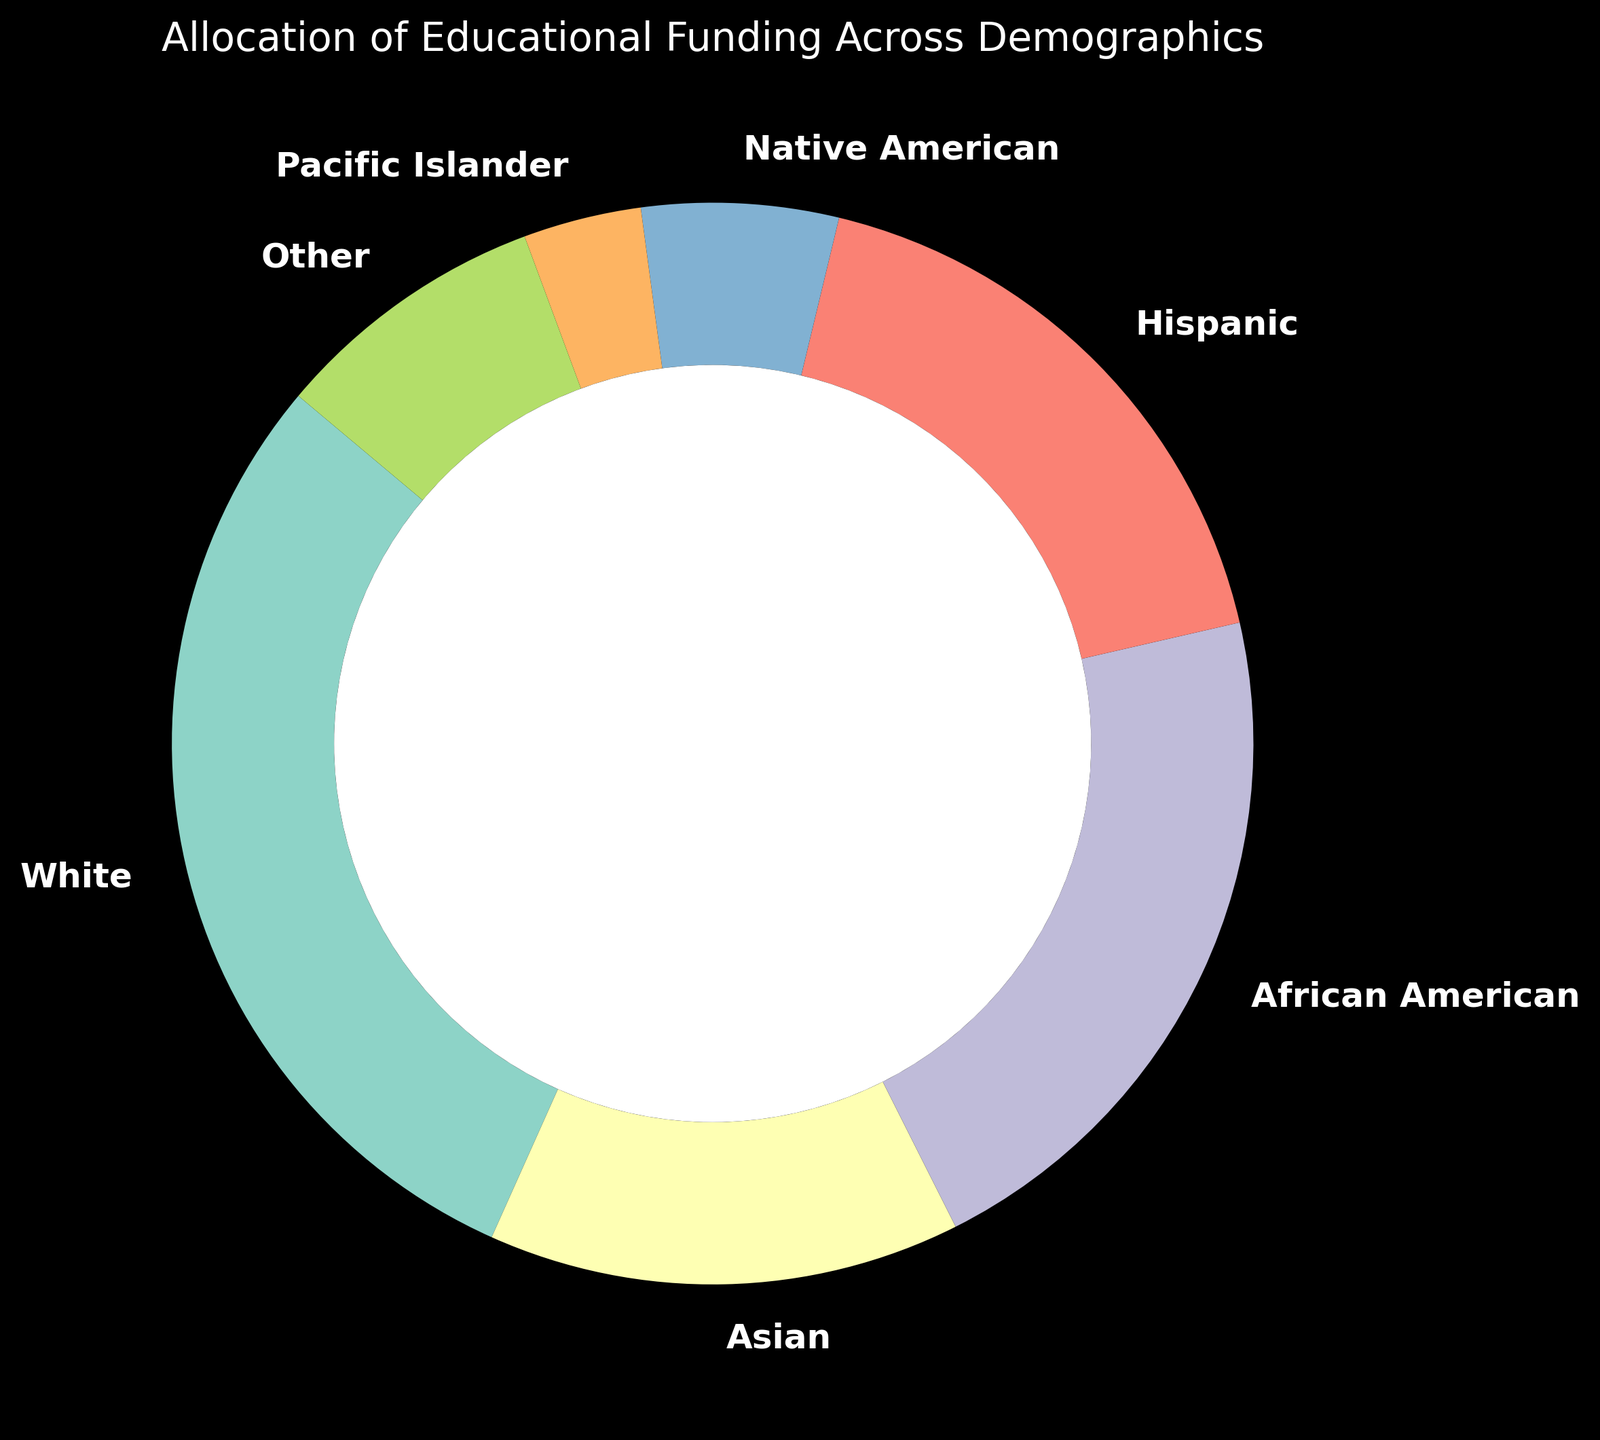Which demographic received the highest amount of funding? By looking at the ring chart, the demographic with the largest section represents the highest funding. The "White" demographic has the largest section.
Answer: White What's the sum of funding allocated to African American, Hispanic, and Native American demographics? The funding amounts for African American, Hispanic, and Native American demographics are 1,800,000, 1,500,000, and 500,000 respectively. Summing these values gives 1,800,000 + 1,500,000 + 500,000 = 3,800,000.
Answer: 3,800,000 How much more funding did the White demographic receive compared to the Asian demographic? The White demographic received 2,500,000 and the Asian demographic received 1,200,000. The difference is calculated as 2,500,000 - 1,200,000 = 1,300,000.
Answer: 1,300,000 What's the percentage of the total funding allocated to Pacific Islander and Other demographics combined? First, sum the funding for Pacific Islander and Other demographics (300,000 + 700,000 = 1,000,000). Then, sum the total funding (2,500,000 + 1,200,000 + 1,800,000 + 1,500,000 + 500,000 + 300,000 + 700,000 = 8,500,000). Finally, find the percentage: (1,000,000 / 8,500,000) * 100 ≈ 11.8%.
Answer: 11.8% Which demographic received the least amount of funding? The ring chart shows the smallest section for the "Pacific Islander" demographic, indicating it received the least funding.
Answer: Pacific Islander Compare the funding received by Hispanic and Asian demographics. Which one is higher? According to the chart, the Hispanic demographic received 1,500,000 while the Asian demographic received 1,200,000. Thus, the Hispanic demographic received more funding.
Answer: Hispanic What is the total funding allocated to minority groups (non-White demographics)? Sum the funding for all non-White demographics: Asian (1,200,000), African American (1,800,000), Hispanic (1,500,000), Native American (500,000), Pacific Islander (300,000), and Other (700,000). The total is 1,200,000 + 1,800,000 + 1,500,000 + 500,000 + 300,000 + 700,000 = 6,000,000.
Answer: 6,000,000 What percentage of the total funding is allocated to the White demographic? The White demographic received 2,500,000 out of a total of 8,500,000. The percentage is calculated as (2,500,000 / 8,500,000) * 100 ≈ 29.4%.
Answer: 29.4% What's the average amount of funding received per demographic category? The total funding is 8,500,000 and there are 7 demographic categories. The average is 8,500,000 / 7 ≈ 1,214,286.
Answer: 1,214,286 